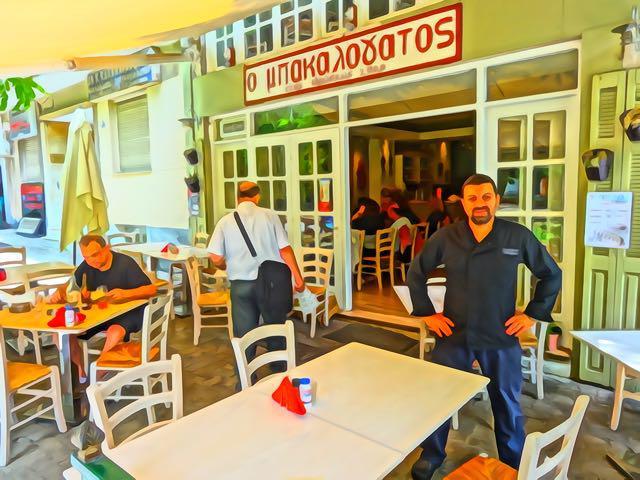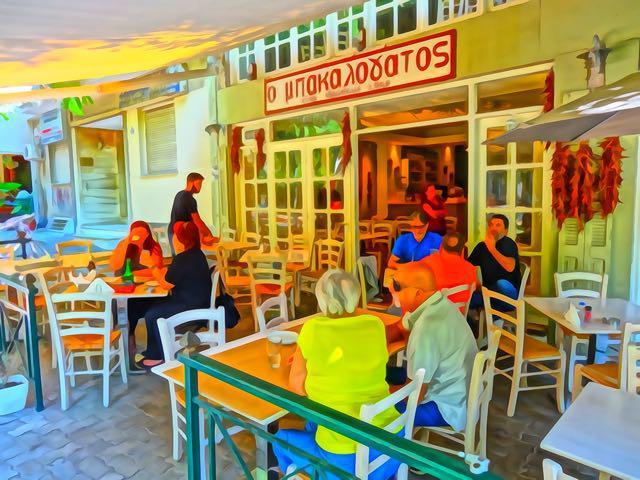The first image is the image on the left, the second image is the image on the right. Assess this claim about the two images: "The left image features a man standing and facing-forward in the middle of rectangular tables with rail-backed chairs around them.". Correct or not? Answer yes or no. Yes. The first image is the image on the left, the second image is the image on the right. Assess this claim about the two images: "All of the tables are covered with cloths.". Correct or not? Answer yes or no. No. 